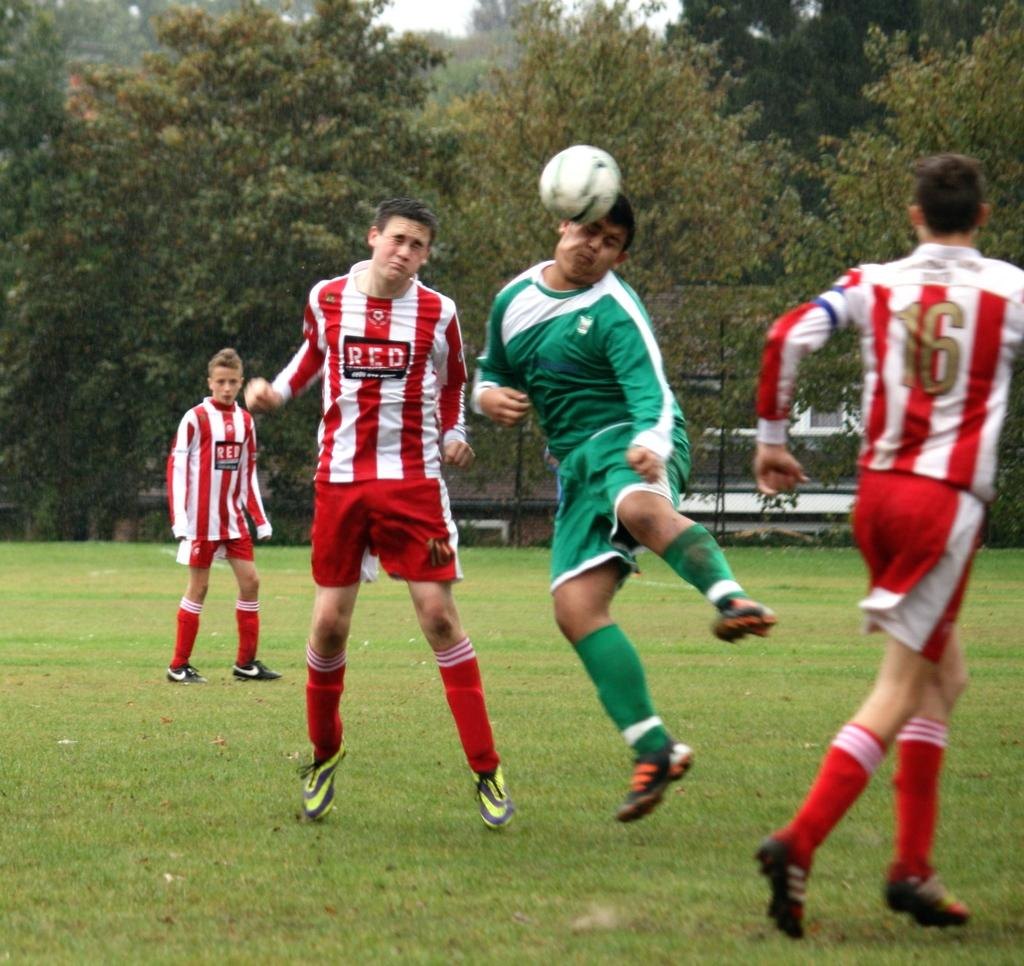What can be seen in the background of the image? There are trees in the background of the image. How many people are present in the image? There are four persons in the image. What are the four persons doing in the image? The four persons are playing a game. Where is the game being played? The game is being played on a ground. How would you describe the condition of the grass on the ground? The grass on the ground is fresh and green. What object is involved in the game being played? There is a ball involved in the game. Can you tell me how many beetles are crawling on the ball in the image? There are no beetles visible in the image, and therefore no such activity can be observed. What is the best way to rest after playing the game in the image? The provided facts do not give information about resting or any specific way to do so after playing the game. 